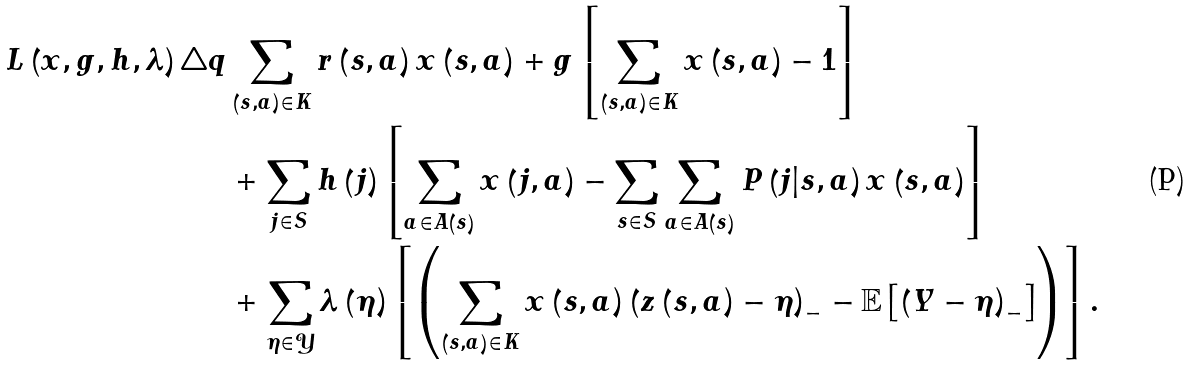Convert formula to latex. <formula><loc_0><loc_0><loc_500><loc_500>L \left ( x , g , h , \lambda \right ) \triangle q & \sum _ { \left ( s , a \right ) \in K } r \left ( s , a \right ) x \left ( s , a \right ) + g \left [ \sum _ { \left ( s , a \right ) \in K } x \left ( s , a \right ) - 1 \right ] \\ & + \sum _ { j \in S } h \left ( j \right ) \left [ \sum _ { a \in A \left ( s \right ) } x \left ( j , a \right ) - \sum _ { s \in S } \sum _ { a \in A \left ( s \right ) } P \left ( j | s , a \right ) x \left ( s , a \right ) \right ] \\ & + \sum _ { \eta \in \mathcal { Y } } \lambda \left ( \eta \right ) \left [ \left ( \sum _ { \left ( s , a \right ) \in K } x \left ( s , a \right ) \left ( z \left ( s , a \right ) - \eta \right ) _ { - } - \mathbb { E } \left [ \left ( Y - \eta \right ) _ { - } \right ] \right ) \right ] .</formula> 